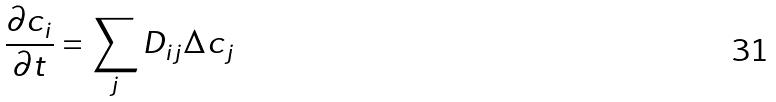<formula> <loc_0><loc_0><loc_500><loc_500>\frac { \partial c _ { i } } { \partial t } = \sum _ { j } D _ { i j } \Delta c _ { j }</formula> 